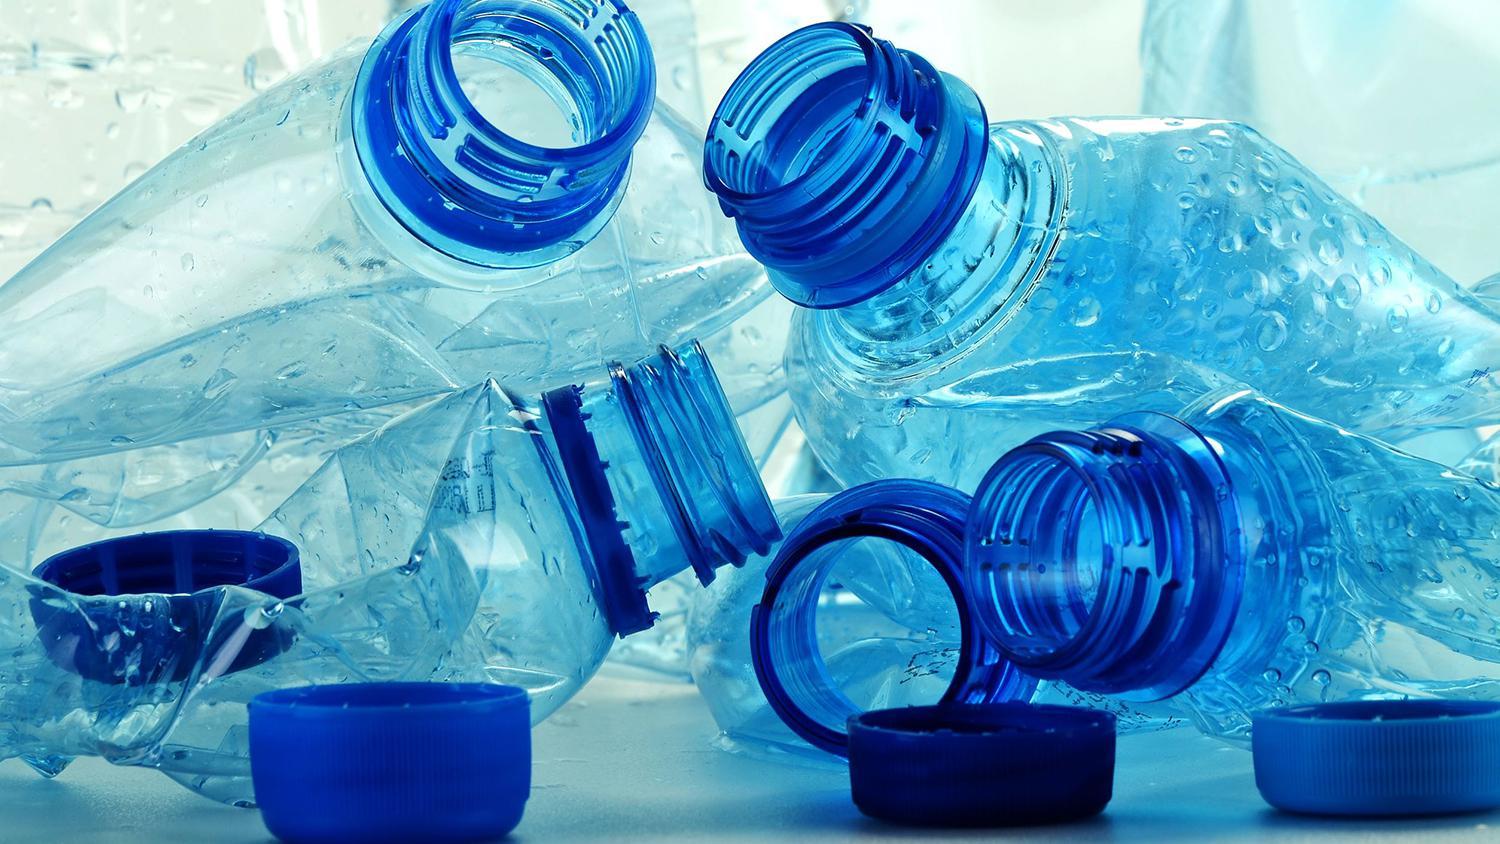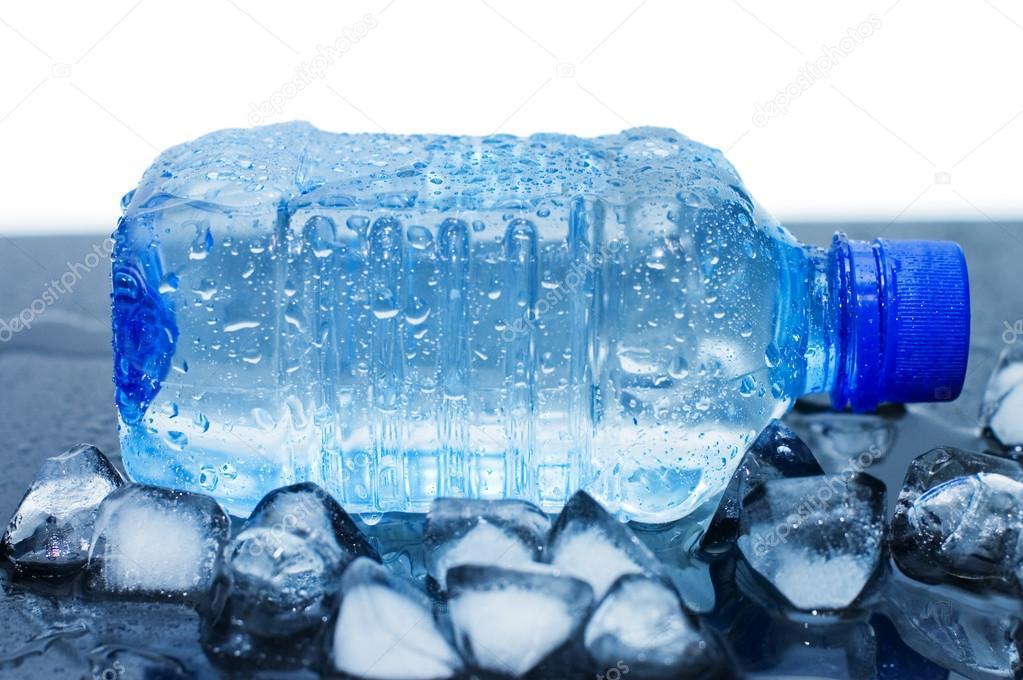The first image is the image on the left, the second image is the image on the right. For the images displayed, is the sentence "There are exactly four bottles of water in one of the images." factually correct? Answer yes or no. No. 